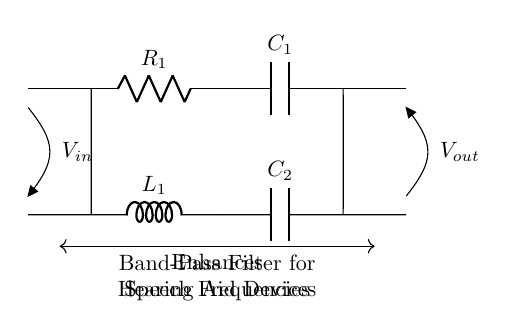What is the type of filter represented in this circuit? The circuit is specifically designed as a band-pass filter, indicated by the arrangement of components (resistors, inductors, and capacitors) that allow certain frequency ranges to pass while attenuating others.
Answer: band-pass filter What components are used in this circuit? The circuit includes a resistor, an inductor, and two capacitors, which are essential for creating the filtering effect at specific frequencies.
Answer: resistor, inductor, capacitors What is the function of this filter in hearing aids? The primary function of a band-pass filter in hearing aids is to enhance speech frequencies, allowing for clearer communication by amplifying sounds within a specific range while reducing background noise outside that range.
Answer: enhance speech frequencies Where does the input voltage enter the circuit? The input voltage enters the circuit at the left side where the notation "V_in" is marked, connecting to the first component, the resistor.
Answer: left side What is the output voltage indicated in the circuit? The output voltage is indicated at the right side of the circuit where the notation "V_out" is marked, connected to the last component in the filter path.
Answer: right side How do the inductor and capacitors interact in this circuit? The inductor and capacitors work together to create a selective frequency response. The inductor allows certain frequencies to pass while blocking others, and the configuration of the capacitors adjusts the cutoff frequencies, defining the passband of the filter.
Answer: create selective frequency response What does the arrow in the diagram indicate about the output voltage? The arrow pointing towards "V_out" suggests that this is where the output voltage can be measured, indicating the voltage level that is subject to the band's filtration effect.
Answer: measurement point of output voltage 